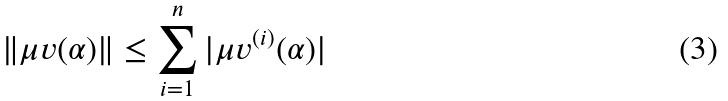<formula> <loc_0><loc_0><loc_500><loc_500>\| \mu v ( \alpha ) \| \leq \sum _ { i = 1 } ^ { n } | { \mu v } ^ { ( i ) } ( \alpha ) |</formula> 